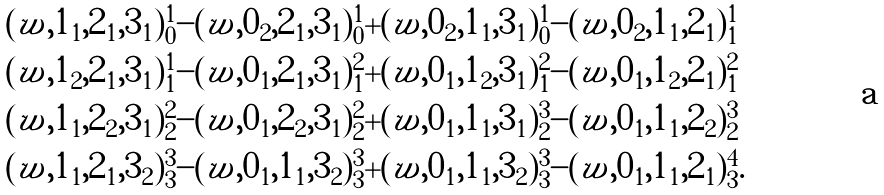<formula> <loc_0><loc_0><loc_500><loc_500>& ( w , 1 _ { 1 } , 2 _ { 1 } , 3 _ { 1 } ) _ { 0 } ^ { 1 } - ( w , 0 _ { 2 } , 2 _ { 1 } , 3 _ { 1 } ) ^ { 1 } _ { 0 } + ( w , 0 _ { 2 } , 1 _ { 1 } , 3 _ { 1 } ) _ { 0 } ^ { 1 } - ( w , 0 _ { 2 } , 1 _ { 1 } , 2 _ { 1 } ) _ { 1 } ^ { 1 } \\ & ( w , 1 _ { 2 } , 2 _ { 1 } , 3 _ { 1 } ) ^ { 1 } _ { 1 } - ( w , 0 _ { 1 } , 2 _ { 1 } , 3 _ { 1 } ) _ { 1 } ^ { 2 } + ( w , 0 _ { 1 } , 1 _ { 2 } , 3 _ { 1 } ) ^ { 2 } _ { 1 } - ( w , 0 _ { 1 } , 1 _ { 2 } , 2 _ { 1 } ) ^ { 2 } _ { 1 } \\ & ( w , 1 _ { 1 } , 2 _ { 2 } , 3 _ { 1 } ) ^ { 2 } _ { 2 } - ( w , 0 _ { 1 } , 2 _ { 2 } , 3 _ { 1 } ) ^ { 2 } _ { 2 } + ( w , 0 _ { 1 } , 1 _ { 1 } , 3 _ { 1 } ) _ { 2 } ^ { 3 } - ( w , 0 _ { 1 } , 1 _ { 1 } , 2 _ { 2 } ) ^ { 3 } _ { 2 } \\ & ( w , 1 _ { 1 } , 2 _ { 1 } , 3 _ { 2 } ) ^ { 3 } _ { 3 } - ( w , 0 _ { 1 } , 1 _ { 1 } , 3 _ { 2 } ) _ { 3 } ^ { 3 } + ( w , 0 _ { 1 } , 1 _ { 1 } , 3 _ { 2 } ) _ { 3 } ^ { 3 } - ( w , 0 _ { 1 } , 1 _ { 1 } , 2 _ { 1 } ) ^ { 4 } _ { 3 } .</formula> 